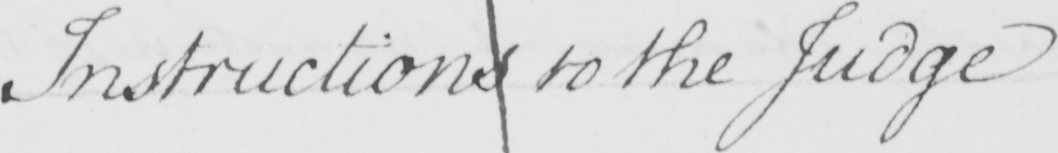Can you tell me what this handwritten text says? Instructions to the Judge 